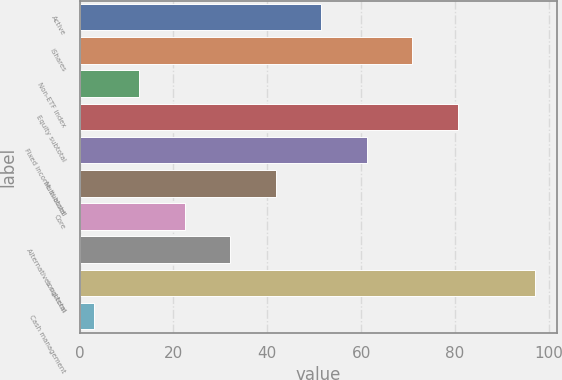<chart> <loc_0><loc_0><loc_500><loc_500><bar_chart><fcel>Active<fcel>iShares<fcel>Non-ETF index<fcel>Equity subtotal<fcel>Fixed income subtotal<fcel>Multi-asset<fcel>Core<fcel>Alternatives subtotal<fcel>Long-term<fcel>Cash management<nl><fcel>51.5<fcel>70.9<fcel>12.7<fcel>80.6<fcel>61.2<fcel>41.8<fcel>22.4<fcel>32.1<fcel>97<fcel>3<nl></chart> 